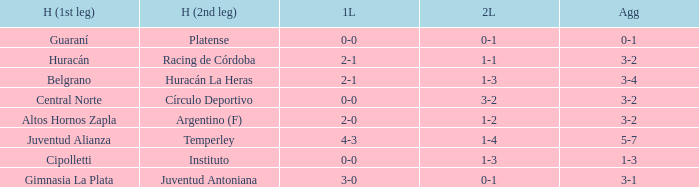Help me parse the entirety of this table. {'header': ['H (1st leg)', 'H (2nd leg)', '1L', '2L', 'Agg'], 'rows': [['Guaraní', 'Platense', '0-0', '0-1', '0-1'], ['Huracán', 'Racing de Córdoba', '2-1', '1-1', '3-2'], ['Belgrano', 'Huracán La Heras', '2-1', '1-3', '3-4'], ['Central Norte', 'Círculo Deportivo', '0-0', '3-2', '3-2'], ['Altos Hornos Zapla', 'Argentino (F)', '2-0', '1-2', '3-2'], ['Juventud Alianza', 'Temperley', '4-3', '1-4', '5-7'], ['Cipolletti', 'Instituto', '0-0', '1-3', '1-3'], ['Gimnasia La Plata', 'Juventud Antoniana', '3-0', '0-1', '3-1']]} Which team played their first leg at home with an aggregate score of 3-4? Belgrano. 